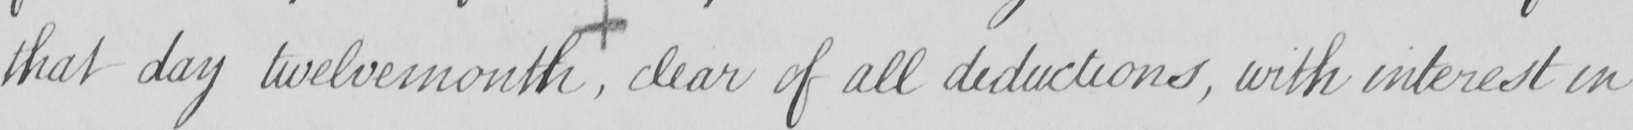Please provide the text content of this handwritten line. that day twelvemonth , clear of all deductions , with interest in 